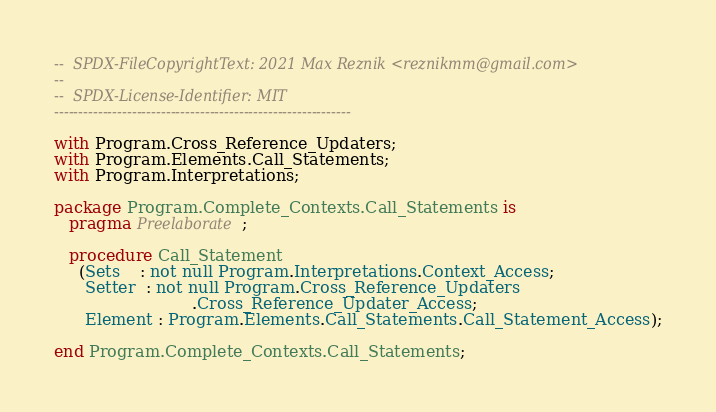<code> <loc_0><loc_0><loc_500><loc_500><_Ada_>--  SPDX-FileCopyrightText: 2021 Max Reznik <reznikmm@gmail.com>
--
--  SPDX-License-Identifier: MIT
-------------------------------------------------------------

with Program.Cross_Reference_Updaters;
with Program.Elements.Call_Statements;
with Program.Interpretations;

package Program.Complete_Contexts.Call_Statements is
   pragma Preelaborate;

   procedure Call_Statement
     (Sets    : not null Program.Interpretations.Context_Access;
      Setter  : not null Program.Cross_Reference_Updaters
                           .Cross_Reference_Updater_Access;
      Element : Program.Elements.Call_Statements.Call_Statement_Access);

end Program.Complete_Contexts.Call_Statements;
</code> 